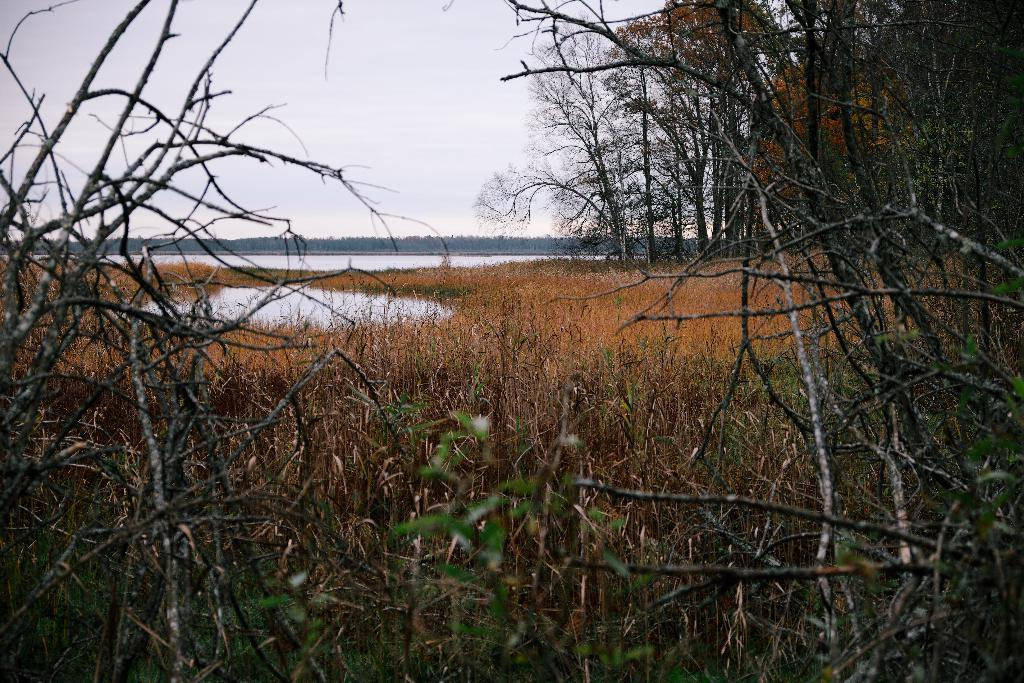What is located in the foreground of the image? There are plants in the foreground of the image. What is visible in the background of the image? There is a lake and trees in the background of the image. What can be seen at the top of the image? The sky is visible at the top of the image. What type of action is being performed by the quilt in the image? There is no quilt present in the image, so no action can be attributed to it. How many fingers can be seen interacting with the plants in the image? There are no fingers visible in the image; it only shows plants in the foreground. 